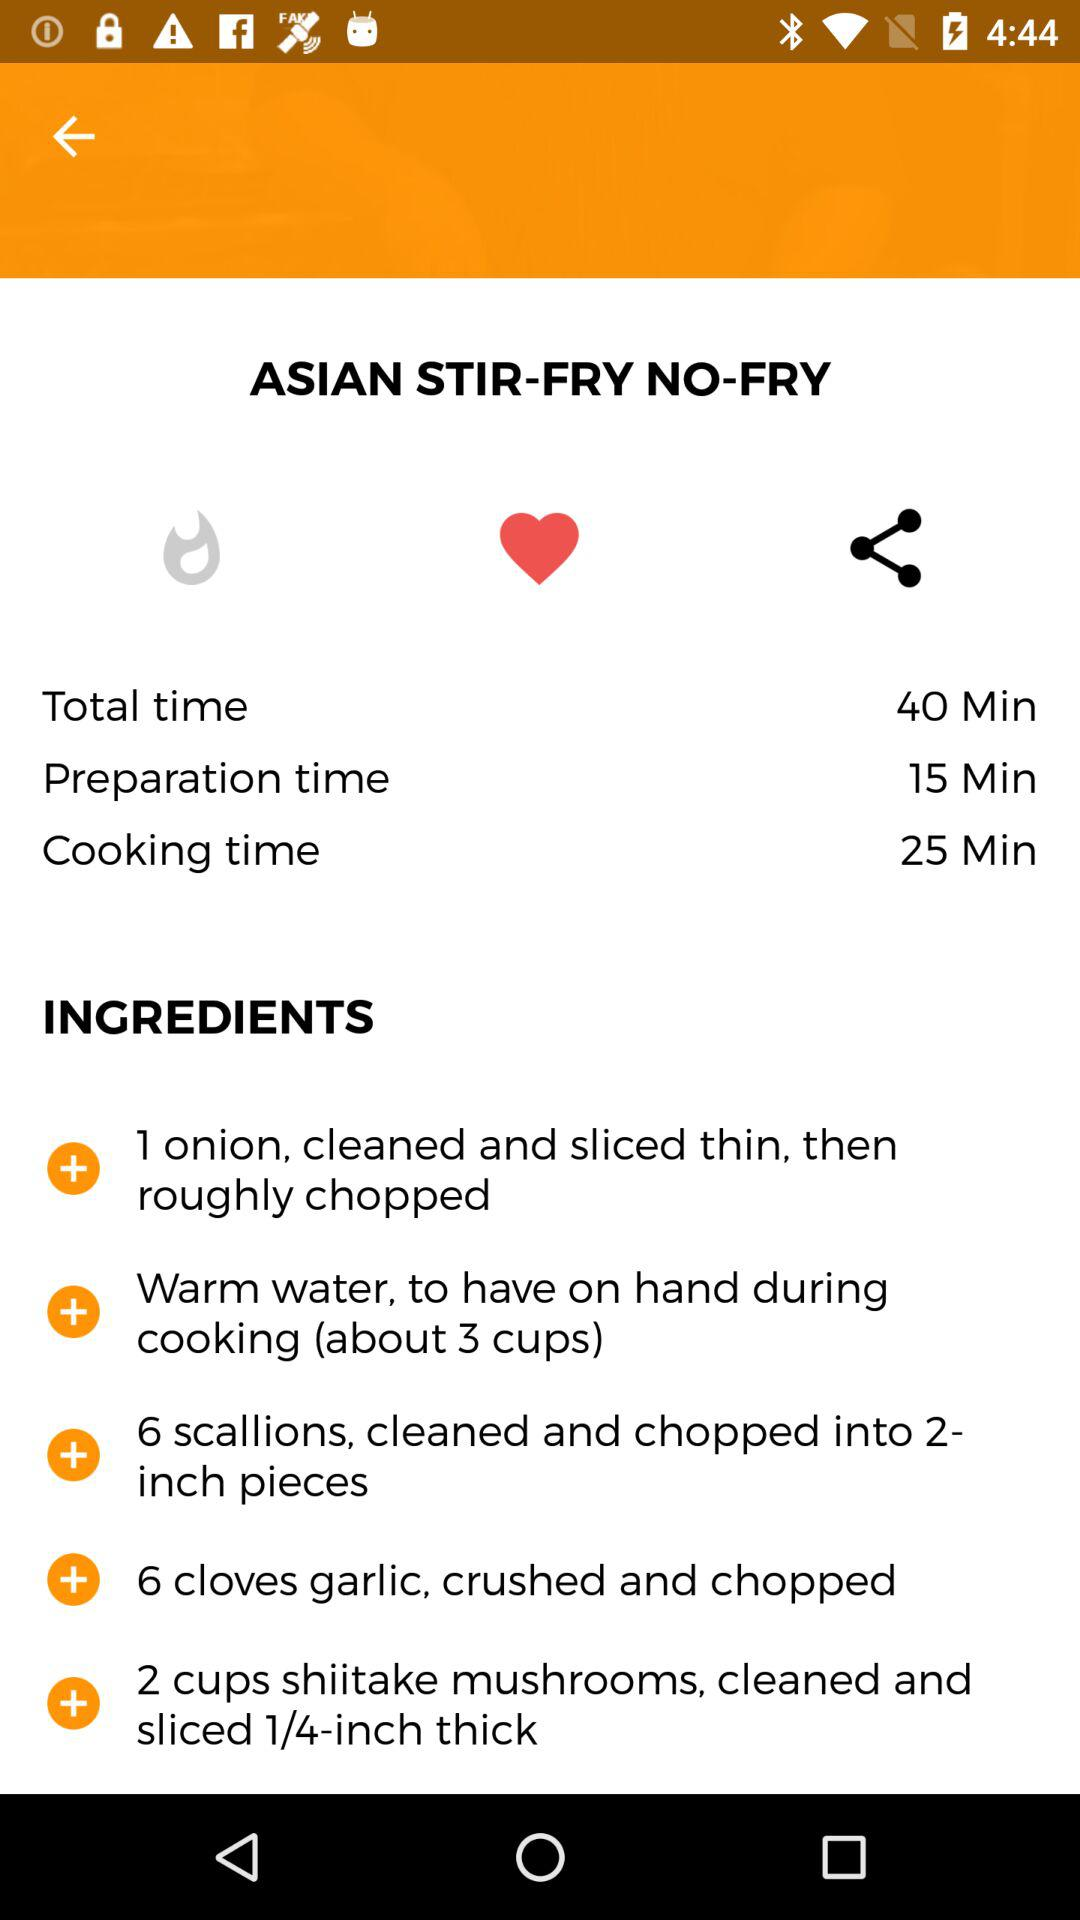What is the name of the dish? The name is "ASIAN STIR-FRY NO-FRY". 